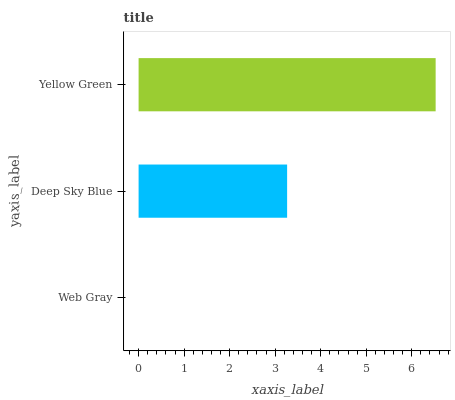Is Web Gray the minimum?
Answer yes or no. Yes. Is Yellow Green the maximum?
Answer yes or no. Yes. Is Deep Sky Blue the minimum?
Answer yes or no. No. Is Deep Sky Blue the maximum?
Answer yes or no. No. Is Deep Sky Blue greater than Web Gray?
Answer yes or no. Yes. Is Web Gray less than Deep Sky Blue?
Answer yes or no. Yes. Is Web Gray greater than Deep Sky Blue?
Answer yes or no. No. Is Deep Sky Blue less than Web Gray?
Answer yes or no. No. Is Deep Sky Blue the high median?
Answer yes or no. Yes. Is Deep Sky Blue the low median?
Answer yes or no. Yes. Is Web Gray the high median?
Answer yes or no. No. Is Yellow Green the low median?
Answer yes or no. No. 